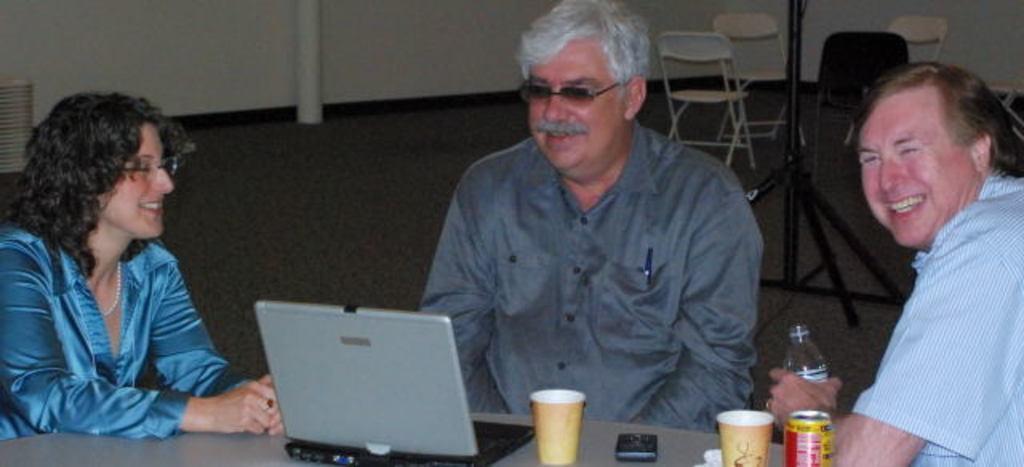Describe this image in one or two sentences. Here I can see two men and a woman are sitting around the table and smiling. On the table a laptop, glasses and a mobile are placed. The man who is on the right side is holding a bottle in the hand. In the background there is a metal stand and few chairs. At the top of the image there is a pole and a wall. 